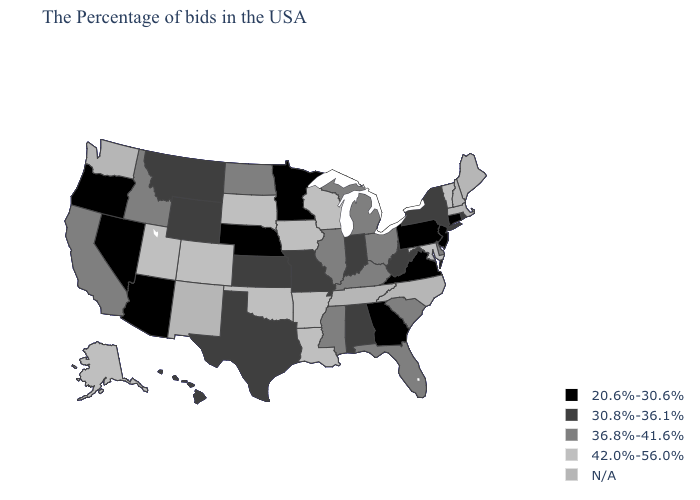Which states hav the highest value in the South?
Write a very short answer. Maryland, Louisiana, Arkansas, Oklahoma. What is the lowest value in states that border West Virginia?
Concise answer only. 20.6%-30.6%. Among the states that border Tennessee , does Kentucky have the lowest value?
Give a very brief answer. No. What is the highest value in the South ?
Keep it brief. 42.0%-56.0%. Does the map have missing data?
Keep it brief. Yes. What is the lowest value in the South?
Give a very brief answer. 20.6%-30.6%. Name the states that have a value in the range 30.8%-36.1%?
Give a very brief answer. Rhode Island, New York, West Virginia, Indiana, Alabama, Missouri, Kansas, Texas, Wyoming, Montana, Hawaii. Is the legend a continuous bar?
Short answer required. No. What is the highest value in states that border Oklahoma?
Keep it brief. 42.0%-56.0%. Which states hav the highest value in the MidWest?
Concise answer only. Wisconsin, Iowa, South Dakota. Does the map have missing data?
Write a very short answer. Yes. What is the value of Mississippi?
Answer briefly. 36.8%-41.6%. What is the value of Michigan?
Quick response, please. 36.8%-41.6%. Among the states that border Vermont , which have the highest value?
Write a very short answer. New York. Name the states that have a value in the range 30.8%-36.1%?
Keep it brief. Rhode Island, New York, West Virginia, Indiana, Alabama, Missouri, Kansas, Texas, Wyoming, Montana, Hawaii. 